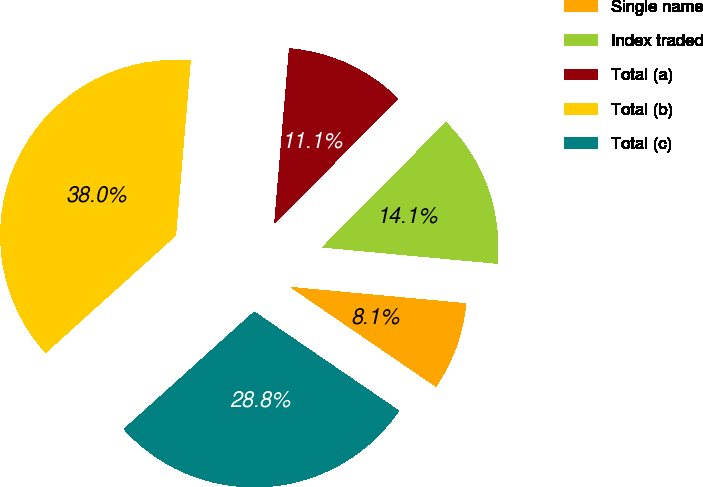Convert chart to OTSL. <chart><loc_0><loc_0><loc_500><loc_500><pie_chart><fcel>Single name<fcel>Index traded<fcel>Total (a)<fcel>Total (b)<fcel>Total (c)<nl><fcel>8.08%<fcel>14.06%<fcel>11.07%<fcel>38.01%<fcel>28.77%<nl></chart> 